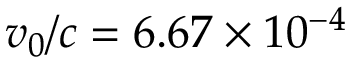Convert formula to latex. <formula><loc_0><loc_0><loc_500><loc_500>v _ { 0 } / c = 6 . 6 7 \times 1 0 ^ { - 4 }</formula> 